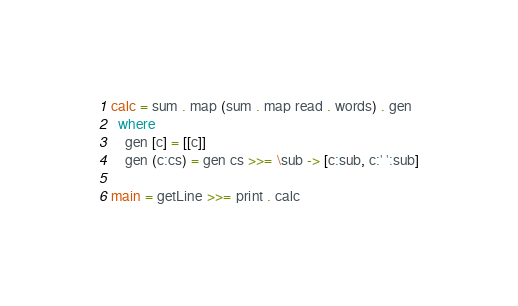<code> <loc_0><loc_0><loc_500><loc_500><_Haskell_>calc = sum . map (sum . map read . words) . gen
  where
    gen [c] = [[c]]
    gen (c:cs) = gen cs >>= \sub -> [c:sub, c:' ':sub]

main = getLine >>= print . calc</code> 